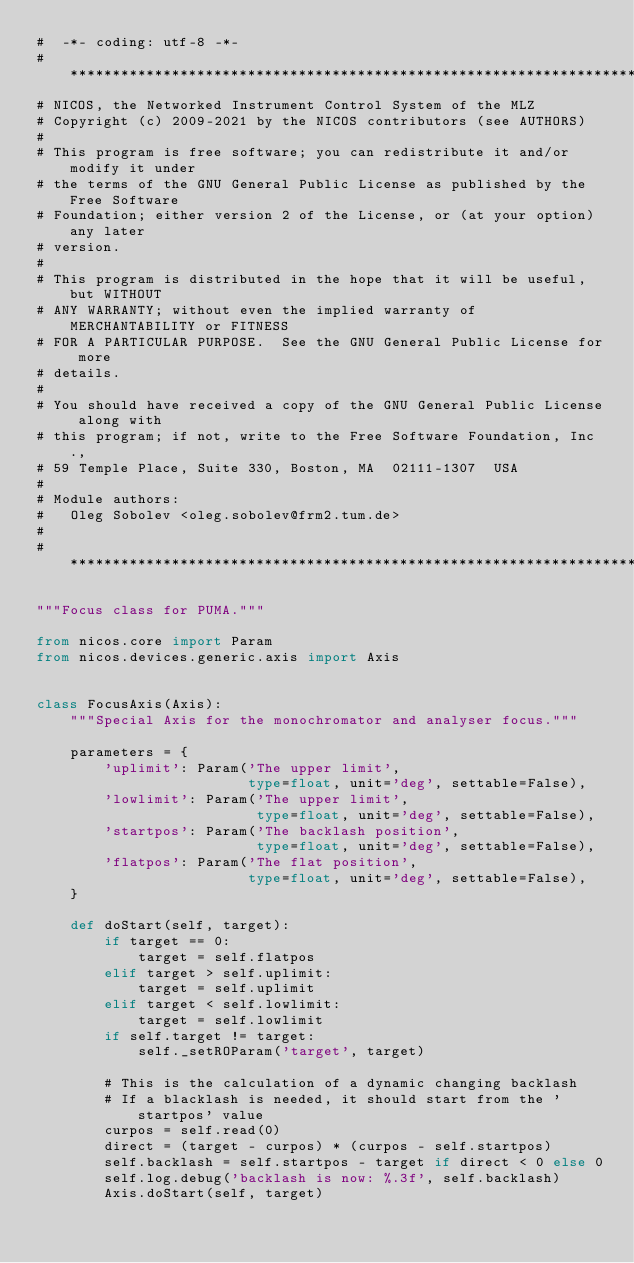Convert code to text. <code><loc_0><loc_0><loc_500><loc_500><_Python_>#  -*- coding: utf-8 -*-
# *****************************************************************************
# NICOS, the Networked Instrument Control System of the MLZ
# Copyright (c) 2009-2021 by the NICOS contributors (see AUTHORS)
#
# This program is free software; you can redistribute it and/or modify it under
# the terms of the GNU General Public License as published by the Free Software
# Foundation; either version 2 of the License, or (at your option) any later
# version.
#
# This program is distributed in the hope that it will be useful, but WITHOUT
# ANY WARRANTY; without even the implied warranty of MERCHANTABILITY or FITNESS
# FOR A PARTICULAR PURPOSE.  See the GNU General Public License for more
# details.
#
# You should have received a copy of the GNU General Public License along with
# this program; if not, write to the Free Software Foundation, Inc.,
# 59 Temple Place, Suite 330, Boston, MA  02111-1307  USA
#
# Module authors:
#   Oleg Sobolev <oleg.sobolev@frm2.tum.de>
#
# *****************************************************************************

"""Focus class for PUMA."""

from nicos.core import Param
from nicos.devices.generic.axis import Axis


class FocusAxis(Axis):
    """Special Axis for the monochromator and analyser focus."""

    parameters = {
        'uplimit': Param('The upper limit',
                         type=float, unit='deg', settable=False),
        'lowlimit': Param('The upper limit',
                          type=float, unit='deg', settable=False),
        'startpos': Param('The backlash position',
                          type=float, unit='deg', settable=False),
        'flatpos': Param('The flat position',
                         type=float, unit='deg', settable=False),
    }

    def doStart(self, target):
        if target == 0:
            target = self.flatpos
        elif target > self.uplimit:
            target = self.uplimit
        elif target < self.lowlimit:
            target = self.lowlimit
        if self.target != target:
            self._setROParam('target', target)

        # This is the calculation of a dynamic changing backlash
        # If a blacklash is needed, it should start from the 'startpos' value
        curpos = self.read(0)
        direct = (target - curpos) * (curpos - self.startpos)
        self.backlash = self.startpos - target if direct < 0 else 0
        self.log.debug('backlash is now: %.3f', self.backlash)
        Axis.doStart(self, target)
</code> 